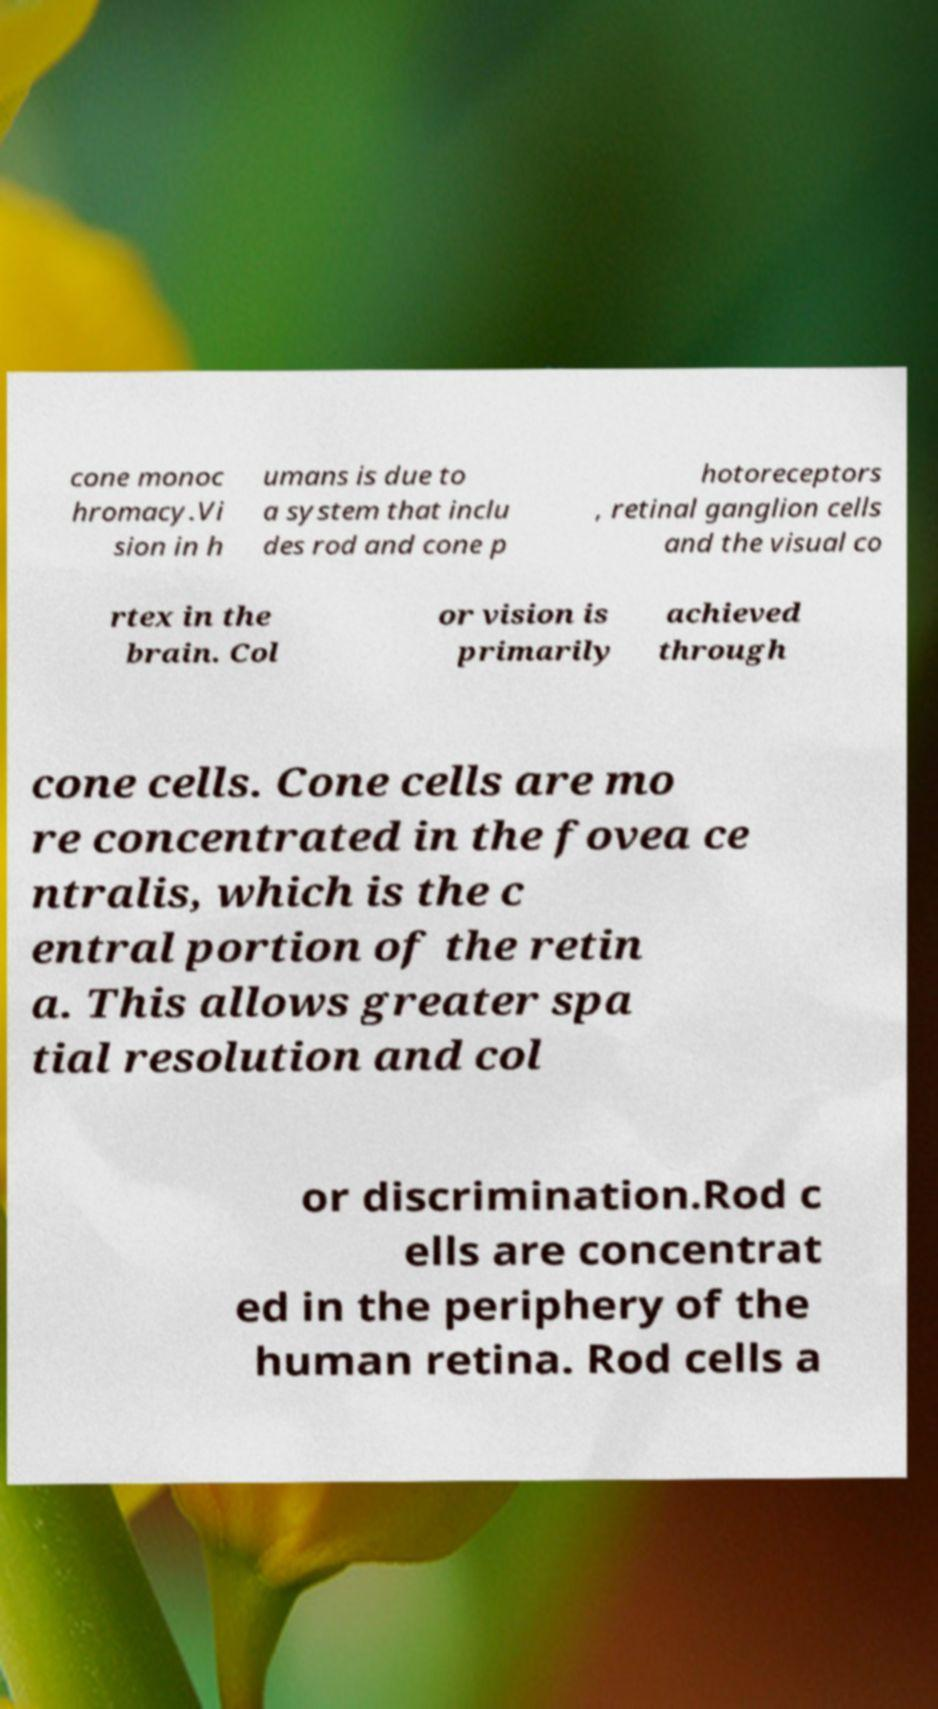Could you extract and type out the text from this image? cone monoc hromacy.Vi sion in h umans is due to a system that inclu des rod and cone p hotoreceptors , retinal ganglion cells and the visual co rtex in the brain. Col or vision is primarily achieved through cone cells. Cone cells are mo re concentrated in the fovea ce ntralis, which is the c entral portion of the retin a. This allows greater spa tial resolution and col or discrimination.Rod c ells are concentrat ed in the periphery of the human retina. Rod cells a 